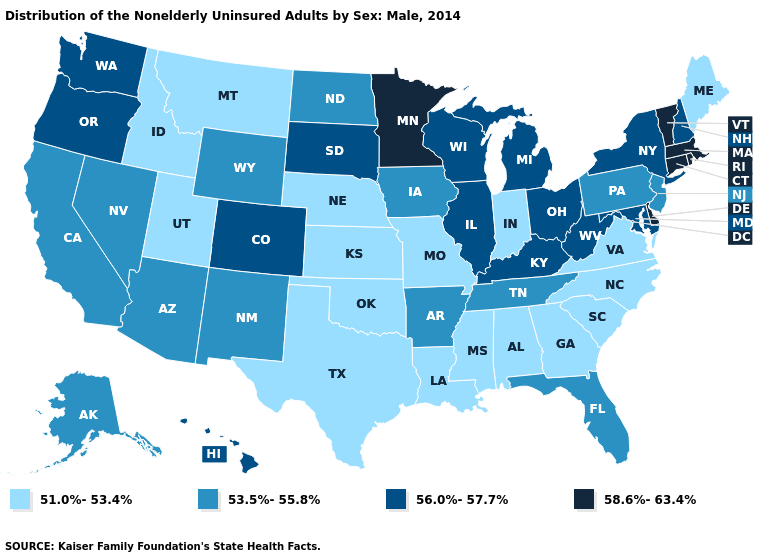Name the states that have a value in the range 56.0%-57.7%?
Short answer required. Colorado, Hawaii, Illinois, Kentucky, Maryland, Michigan, New Hampshire, New York, Ohio, Oregon, South Dakota, Washington, West Virginia, Wisconsin. Name the states that have a value in the range 58.6%-63.4%?
Answer briefly. Connecticut, Delaware, Massachusetts, Minnesota, Rhode Island, Vermont. Name the states that have a value in the range 51.0%-53.4%?
Short answer required. Alabama, Georgia, Idaho, Indiana, Kansas, Louisiana, Maine, Mississippi, Missouri, Montana, Nebraska, North Carolina, Oklahoma, South Carolina, Texas, Utah, Virginia. Does Wyoming have a lower value than Nevada?
Be succinct. No. Name the states that have a value in the range 58.6%-63.4%?
Short answer required. Connecticut, Delaware, Massachusetts, Minnesota, Rhode Island, Vermont. What is the value of Massachusetts?
Be succinct. 58.6%-63.4%. Name the states that have a value in the range 53.5%-55.8%?
Be succinct. Alaska, Arizona, Arkansas, California, Florida, Iowa, Nevada, New Jersey, New Mexico, North Dakota, Pennsylvania, Tennessee, Wyoming. What is the value of Alaska?
Give a very brief answer. 53.5%-55.8%. Does the map have missing data?
Give a very brief answer. No. Name the states that have a value in the range 56.0%-57.7%?
Keep it brief. Colorado, Hawaii, Illinois, Kentucky, Maryland, Michigan, New Hampshire, New York, Ohio, Oregon, South Dakota, Washington, West Virginia, Wisconsin. Name the states that have a value in the range 53.5%-55.8%?
Give a very brief answer. Alaska, Arizona, Arkansas, California, Florida, Iowa, Nevada, New Jersey, New Mexico, North Dakota, Pennsylvania, Tennessee, Wyoming. Which states have the lowest value in the Northeast?
Answer briefly. Maine. Does Kentucky have the highest value in the USA?
Write a very short answer. No. What is the value of Pennsylvania?
Answer briefly. 53.5%-55.8%. 